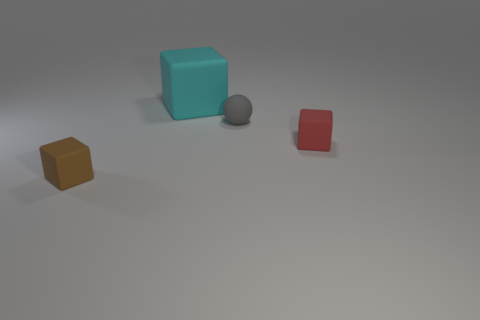Subtract all brown blocks. How many blocks are left? 2 Add 1 small red rubber things. How many objects exist? 5 Subtract 2 cubes. How many cubes are left? 1 Subtract all cubes. How many objects are left? 1 Subtract all large yellow metallic objects. Subtract all rubber spheres. How many objects are left? 3 Add 4 tiny brown things. How many tiny brown things are left? 5 Add 1 gray metallic blocks. How many gray metallic blocks exist? 1 Subtract 0 brown balls. How many objects are left? 4 Subtract all purple blocks. Subtract all green cylinders. How many blocks are left? 3 